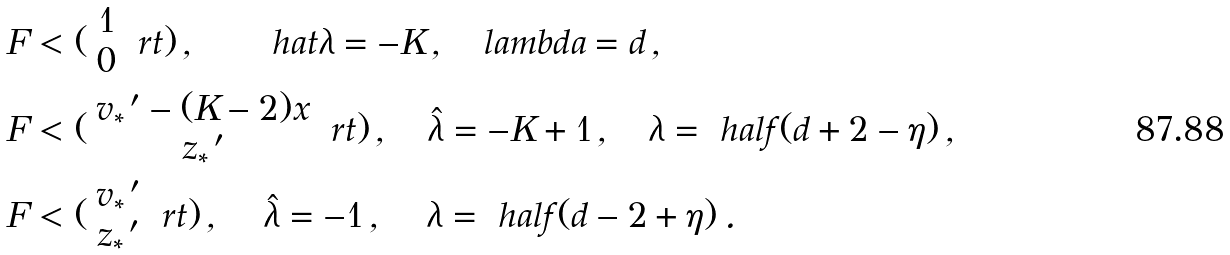<formula> <loc_0><loc_0><loc_500><loc_500>F & < ( \begin{array} { c } 1 \\ 0 \\ \end{array} \ r t ) \, , \quad \ \ \ h a t { \lambda } = - K \, , \quad l a m b d a = d \, , \\ F & < ( \begin{array} { c } v _ { * } { \, } ^ { \prime } - ( K - 2 ) x \\ z _ { * } { \, } ^ { \prime } \\ \end{array} \ r t ) \, , \quad \hat { \lambda } = - K + 1 \, , \quad \lambda = \ h a l f ( d + 2 - \eta ) \, , \\ F & < ( \begin{array} { c } v _ { * } { \, } ^ { \prime } \\ z _ { * } { \, } ^ { \prime } \\ \end{array} \ r t ) \, , \quad \, \hat { \lambda } = - 1 \, , \quad \, \lambda = \ h a l f ( d - 2 + \eta ) \, .</formula> 